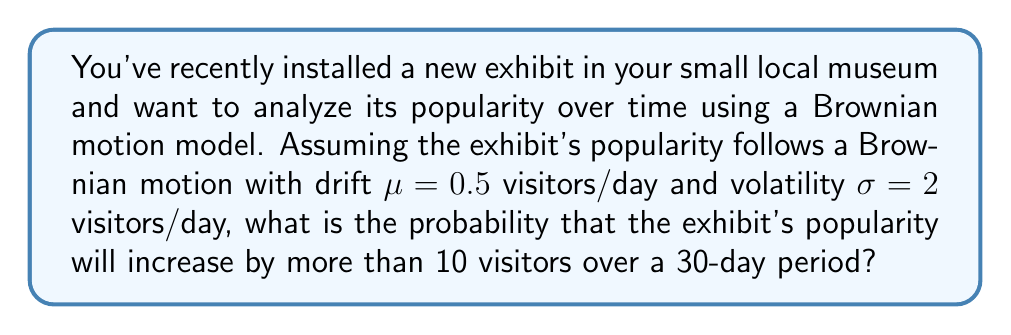Give your solution to this math problem. Let's approach this step-by-step:

1) In a Brownian motion model, the change in popularity over a time period $t$ follows a normal distribution with mean $\mu t$ and variance $\sigma^2 t$.

2) Given:
   - Drift $\mu = 0.5$ visitors/day
   - Volatility $\sigma = 2$ visitors/day
   - Time period $t = 30$ days
   - We want to find $P(X > 10)$ where $X$ is the change in popularity

3) The change in popularity $X$ follows a normal distribution:
   $X \sim N(\mu t, \sigma^2 t)$

4) Calculate the mean:
   $E[X] = \mu t = 0.5 \cdot 30 = 15$ visitors

5) Calculate the variance:
   $Var(X) = \sigma^2 t = 2^2 \cdot 30 = 120$ visitors^2

6) Calculate the standard deviation:
   $SD(X) = \sqrt{Var(X)} = \sqrt{120} \approx 10.95$ visitors

7) To find $P(X > 10)$, we need to standardize the normal distribution:
   $Z = \frac{X - E[X]}{SD(X)} = \frac{10 - 15}{10.95} \approx -0.4566$

8) We want $P(X > 10)$, which is equivalent to $P(Z > -0.4566)$

9) Using the standard normal distribution table or a calculator:
   $P(Z > -0.4566) \approx 0.6760$

Therefore, the probability that the exhibit's popularity will increase by more than 10 visitors over a 30-day period is approximately 0.6760 or 67.60%.
Answer: 0.6760 